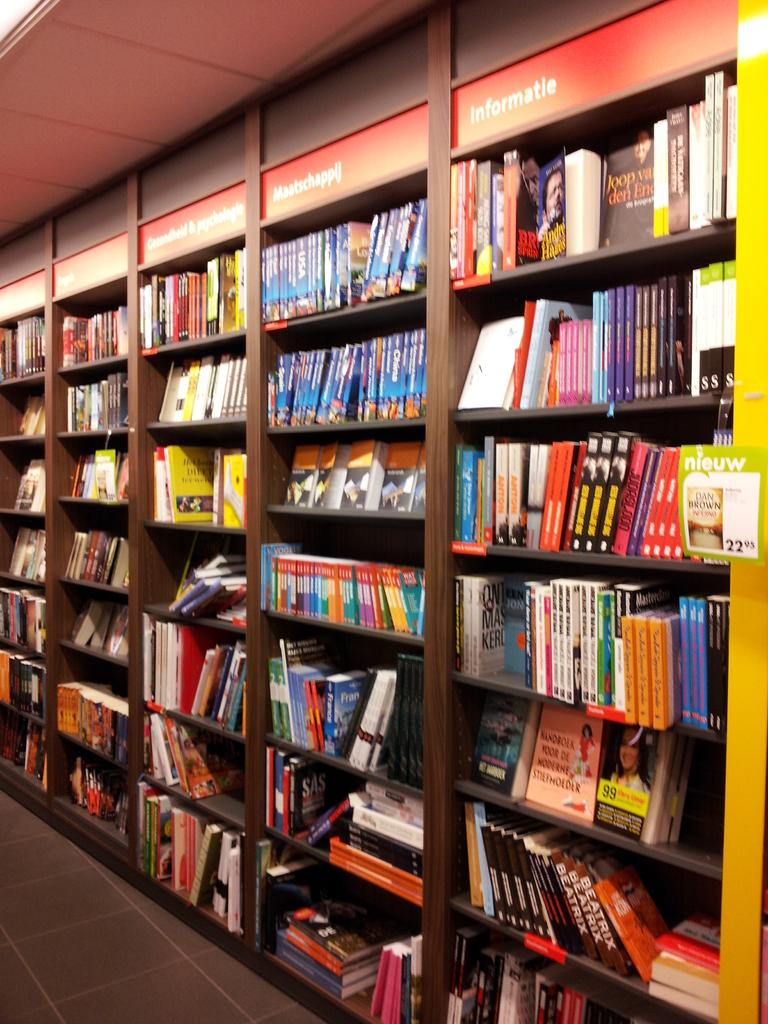What is the main subject of the image? The main subject of the image is a group of books. How are the books arranged in the image? The books are placed in racks. Can you read any text in the image? Yes, there is visible text in the image. What type of structure is visible in the image? There is a roof in the image. Can you see any examples of people kissing in the image? There are no people or any indication of kissing in the image; it primarily features books in racks. 